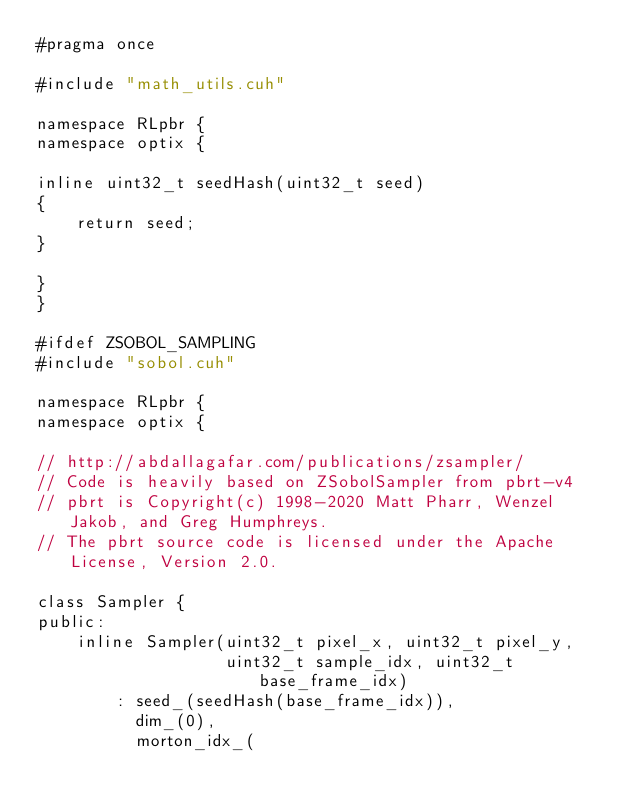Convert code to text. <code><loc_0><loc_0><loc_500><loc_500><_Cuda_>#pragma once

#include "math_utils.cuh"

namespace RLpbr {
namespace optix {

inline uint32_t seedHash(uint32_t seed)
{
    return seed;
}

}
}

#ifdef ZSOBOL_SAMPLING
#include "sobol.cuh"

namespace RLpbr {
namespace optix {

// http://abdallagafar.com/publications/zsampler/
// Code is heavily based on ZSobolSampler from pbrt-v4
// pbrt is Copyright(c) 1998-2020 Matt Pharr, Wenzel Jakob, and Greg Humphreys.
// The pbrt source code is licensed under the Apache License, Version 2.0.

class Sampler {
public:
    inline Sampler(uint32_t pixel_x, uint32_t pixel_y,
                   uint32_t sample_idx, uint32_t base_frame_idx)
        : seed_(seedHash(base_frame_idx)),
          dim_(0),
          morton_idx_(</code> 